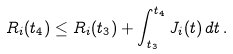<formula> <loc_0><loc_0><loc_500><loc_500>R _ { i } ( t _ { 4 } ) \leq R _ { i } ( t _ { 3 } ) + \int _ { t _ { 3 } } ^ { t _ { 4 } } J _ { i } ( t ) \, d t \, .</formula> 